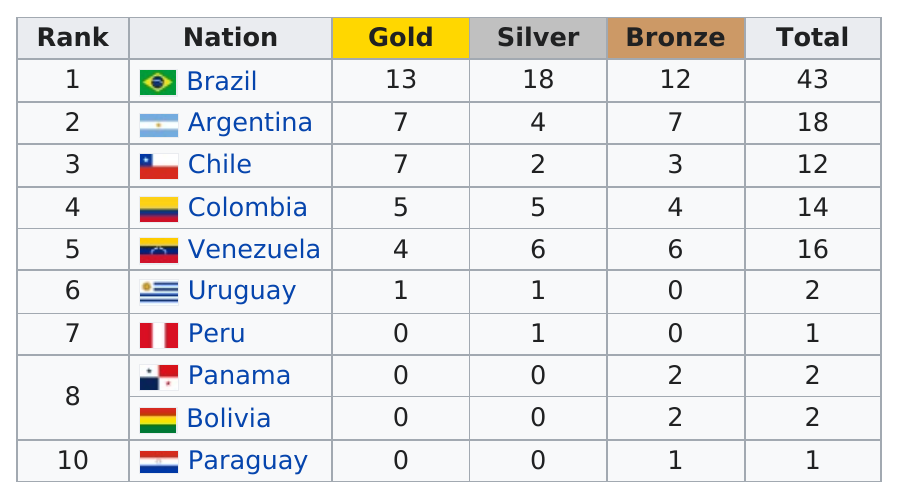Identify some key points in this picture. Chile won two silver medals. Venezuela has more medals than Colombia. Brazil is the top-ranking nation with a total of 43 medals. Peru and Paraguay won the fewest medals among the countries competing in the event. Uruguay and Peru had the lowest number of bronze medals among all participating nations. 